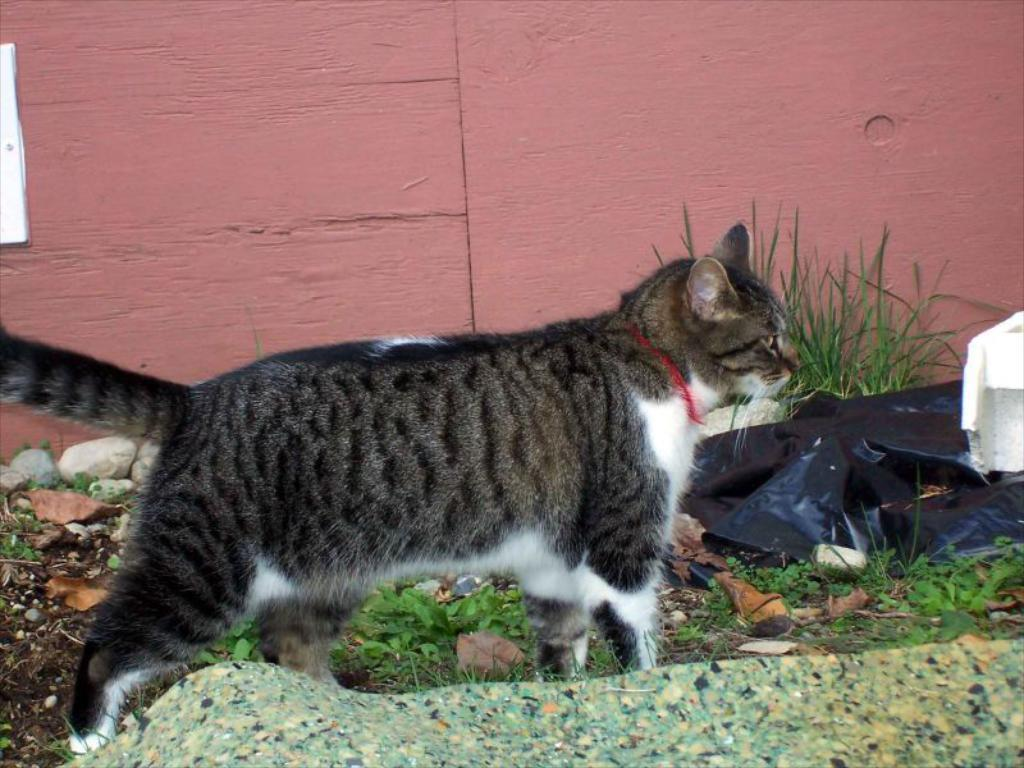What type of animal can be seen in the image? There is a cat in the image. What is covering the object in the image? There is a plastic cover in the image. What type of vegetation is present in the image? There is grass in the image. What type of ground surface is visible in the image? There are stones on the ground in the image. What can be seen in the background of the image? There is a wall visible in the background of the image. How many girls are interacting with the ducks in the image? There are no girls or ducks present in the image. 